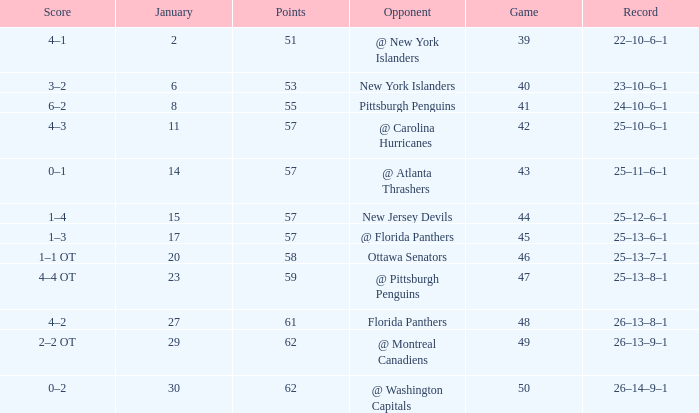What opponent has an average less than 62 and a january average less than 6 @ New York Islanders. Help me parse the entirety of this table. {'header': ['Score', 'January', 'Points', 'Opponent', 'Game', 'Record'], 'rows': [['4–1', '2', '51', '@ New York Islanders', '39', '22–10–6–1'], ['3–2', '6', '53', 'New York Islanders', '40', '23–10–6–1'], ['6–2', '8', '55', 'Pittsburgh Penguins', '41', '24–10–6–1'], ['4–3', '11', '57', '@ Carolina Hurricanes', '42', '25–10–6–1'], ['0–1', '14', '57', '@ Atlanta Thrashers', '43', '25–11–6–1'], ['1–4', '15', '57', 'New Jersey Devils', '44', '25–12–6–1'], ['1–3', '17', '57', '@ Florida Panthers', '45', '25–13–6–1'], ['1–1 OT', '20', '58', 'Ottawa Senators', '46', '25–13–7–1'], ['4–4 OT', '23', '59', '@ Pittsburgh Penguins', '47', '25–13–8–1'], ['4–2', '27', '61', 'Florida Panthers', '48', '26–13–8–1'], ['2–2 OT', '29', '62', '@ Montreal Canadiens', '49', '26–13–9–1'], ['0–2', '30', '62', '@ Washington Capitals', '50', '26–14–9–1']]} 